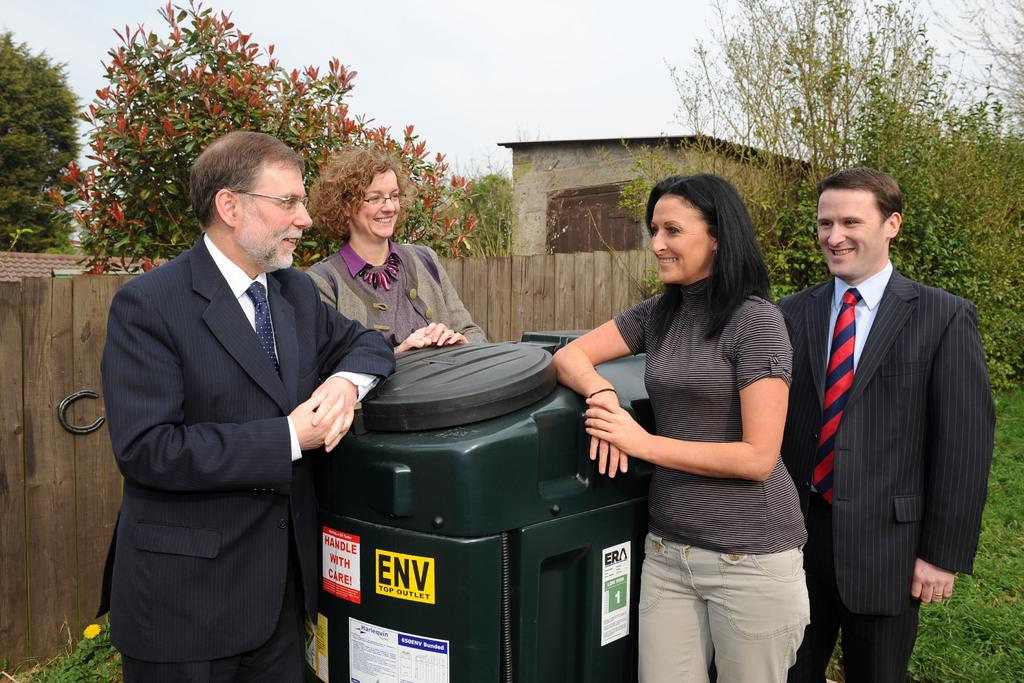<image>
Give a short and clear explanation of the subsequent image. Four people prop themselves again a garbage can that says "Handle with care" on it. 